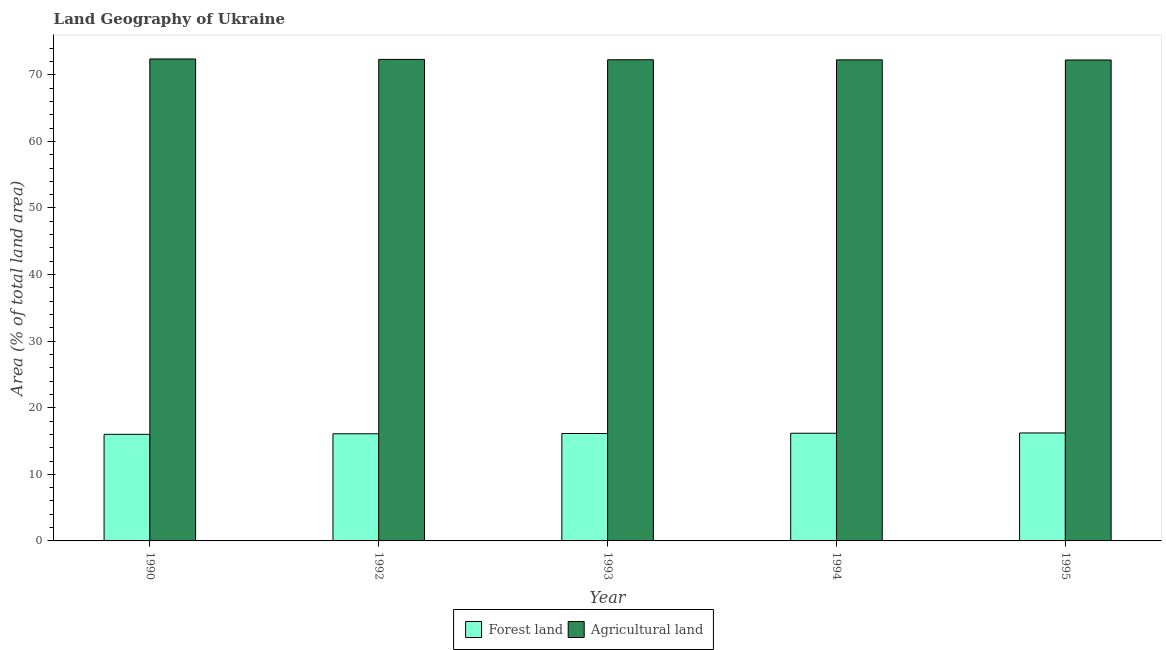How many groups of bars are there?
Give a very brief answer. 5. Are the number of bars per tick equal to the number of legend labels?
Your answer should be very brief. Yes. Are the number of bars on each tick of the X-axis equal?
Make the answer very short. Yes. How many bars are there on the 3rd tick from the left?
Make the answer very short. 2. How many bars are there on the 3rd tick from the right?
Offer a terse response. 2. What is the label of the 1st group of bars from the left?
Offer a very short reply. 1990. What is the percentage of land area under forests in 1993?
Offer a terse response. 16.13. Across all years, what is the maximum percentage of land area under forests?
Make the answer very short. 16.21. Across all years, what is the minimum percentage of land area under agriculture?
Your response must be concise. 72.22. In which year was the percentage of land area under forests minimum?
Ensure brevity in your answer.  1990. What is the total percentage of land area under agriculture in the graph?
Your response must be concise. 361.39. What is the difference between the percentage of land area under forests in 1993 and that in 1995?
Your answer should be very brief. -0.08. What is the difference between the percentage of land area under agriculture in 1994 and the percentage of land area under forests in 1995?
Give a very brief answer. 0.02. What is the average percentage of land area under forests per year?
Ensure brevity in your answer.  16.12. In the year 1995, what is the difference between the percentage of land area under agriculture and percentage of land area under forests?
Make the answer very short. 0. In how many years, is the percentage of land area under forests greater than 52 %?
Your response must be concise. 0. What is the ratio of the percentage of land area under agriculture in 1992 to that in 1993?
Your response must be concise. 1. Is the percentage of land area under forests in 1992 less than that in 1994?
Provide a short and direct response. Yes. Is the difference between the percentage of land area under agriculture in 1993 and 1994 greater than the difference between the percentage of land area under forests in 1993 and 1994?
Make the answer very short. No. What is the difference between the highest and the second highest percentage of land area under forests?
Your answer should be very brief. 0.04. What is the difference between the highest and the lowest percentage of land area under agriculture?
Provide a succinct answer. 0.15. In how many years, is the percentage of land area under agriculture greater than the average percentage of land area under agriculture taken over all years?
Provide a short and direct response. 2. What does the 1st bar from the left in 1995 represents?
Offer a very short reply. Forest land. What does the 2nd bar from the right in 1994 represents?
Make the answer very short. Forest land. How many bars are there?
Your response must be concise. 10. Are all the bars in the graph horizontal?
Give a very brief answer. No. How many years are there in the graph?
Keep it short and to the point. 5. What is the difference between two consecutive major ticks on the Y-axis?
Make the answer very short. 10. Are the values on the major ticks of Y-axis written in scientific E-notation?
Make the answer very short. No. Does the graph contain any zero values?
Your response must be concise. No. Does the graph contain grids?
Ensure brevity in your answer.  No. Where does the legend appear in the graph?
Make the answer very short. Bottom center. How many legend labels are there?
Offer a terse response. 2. How are the legend labels stacked?
Provide a short and direct response. Horizontal. What is the title of the graph?
Keep it short and to the point. Land Geography of Ukraine. Does "Male population" appear as one of the legend labels in the graph?
Ensure brevity in your answer.  No. What is the label or title of the Y-axis?
Provide a succinct answer. Area (% of total land area). What is the Area (% of total land area) of Forest land in 1990?
Your answer should be compact. 16.01. What is the Area (% of total land area) of Agricultural land in 1990?
Provide a short and direct response. 72.37. What is the Area (% of total land area) of Forest land in 1992?
Offer a terse response. 16.09. What is the Area (% of total land area) in Agricultural land in 1992?
Offer a very short reply. 72.31. What is the Area (% of total land area) of Forest land in 1993?
Provide a short and direct response. 16.13. What is the Area (% of total land area) of Agricultural land in 1993?
Give a very brief answer. 72.26. What is the Area (% of total land area) of Forest land in 1994?
Offer a very short reply. 16.17. What is the Area (% of total land area) in Agricultural land in 1994?
Your answer should be compact. 72.24. What is the Area (% of total land area) of Forest land in 1995?
Provide a short and direct response. 16.21. What is the Area (% of total land area) of Agricultural land in 1995?
Make the answer very short. 72.22. Across all years, what is the maximum Area (% of total land area) in Forest land?
Your response must be concise. 16.21. Across all years, what is the maximum Area (% of total land area) in Agricultural land?
Offer a very short reply. 72.37. Across all years, what is the minimum Area (% of total land area) of Forest land?
Offer a very short reply. 16.01. Across all years, what is the minimum Area (% of total land area) of Agricultural land?
Your response must be concise. 72.22. What is the total Area (% of total land area) in Forest land in the graph?
Provide a succinct answer. 80.61. What is the total Area (% of total land area) in Agricultural land in the graph?
Ensure brevity in your answer.  361.39. What is the difference between the Area (% of total land area) in Forest land in 1990 and that in 1992?
Provide a succinct answer. -0.08. What is the difference between the Area (% of total land area) in Agricultural land in 1990 and that in 1992?
Ensure brevity in your answer.  0.07. What is the difference between the Area (% of total land area) in Forest land in 1990 and that in 1993?
Provide a short and direct response. -0.12. What is the difference between the Area (% of total land area) in Agricultural land in 1990 and that in 1993?
Your response must be concise. 0.12. What is the difference between the Area (% of total land area) in Forest land in 1990 and that in 1994?
Offer a very short reply. -0.16. What is the difference between the Area (% of total land area) in Agricultural land in 1990 and that in 1994?
Provide a succinct answer. 0.13. What is the difference between the Area (% of total land area) in Forest land in 1990 and that in 1995?
Your response must be concise. -0.2. What is the difference between the Area (% of total land area) in Agricultural land in 1990 and that in 1995?
Ensure brevity in your answer.  0.15. What is the difference between the Area (% of total land area) of Forest land in 1992 and that in 1993?
Offer a very short reply. -0.04. What is the difference between the Area (% of total land area) in Agricultural land in 1992 and that in 1993?
Give a very brief answer. 0.05. What is the difference between the Area (% of total land area) in Forest land in 1992 and that in 1994?
Provide a short and direct response. -0.08. What is the difference between the Area (% of total land area) in Agricultural land in 1992 and that in 1994?
Your answer should be very brief. 0.06. What is the difference between the Area (% of total land area) in Forest land in 1992 and that in 1995?
Keep it short and to the point. -0.12. What is the difference between the Area (% of total land area) in Agricultural land in 1992 and that in 1995?
Make the answer very short. 0.09. What is the difference between the Area (% of total land area) in Forest land in 1993 and that in 1994?
Keep it short and to the point. -0.04. What is the difference between the Area (% of total land area) in Agricultural land in 1993 and that in 1994?
Your response must be concise. 0.01. What is the difference between the Area (% of total land area) of Forest land in 1993 and that in 1995?
Keep it short and to the point. -0.08. What is the difference between the Area (% of total land area) in Agricultural land in 1993 and that in 1995?
Provide a succinct answer. 0.04. What is the difference between the Area (% of total land area) in Forest land in 1994 and that in 1995?
Provide a succinct answer. -0.04. What is the difference between the Area (% of total land area) in Agricultural land in 1994 and that in 1995?
Keep it short and to the point. 0.02. What is the difference between the Area (% of total land area) in Forest land in 1990 and the Area (% of total land area) in Agricultural land in 1992?
Offer a very short reply. -56.3. What is the difference between the Area (% of total land area) in Forest land in 1990 and the Area (% of total land area) in Agricultural land in 1993?
Offer a very short reply. -56.25. What is the difference between the Area (% of total land area) of Forest land in 1990 and the Area (% of total land area) of Agricultural land in 1994?
Make the answer very short. -56.23. What is the difference between the Area (% of total land area) in Forest land in 1990 and the Area (% of total land area) in Agricultural land in 1995?
Your answer should be very brief. -56.21. What is the difference between the Area (% of total land area) of Forest land in 1992 and the Area (% of total land area) of Agricultural land in 1993?
Provide a succinct answer. -56.17. What is the difference between the Area (% of total land area) of Forest land in 1992 and the Area (% of total land area) of Agricultural land in 1994?
Your answer should be compact. -56.15. What is the difference between the Area (% of total land area) in Forest land in 1992 and the Area (% of total land area) in Agricultural land in 1995?
Your answer should be very brief. -56.13. What is the difference between the Area (% of total land area) of Forest land in 1993 and the Area (% of total land area) of Agricultural land in 1994?
Offer a terse response. -56.11. What is the difference between the Area (% of total land area) of Forest land in 1993 and the Area (% of total land area) of Agricultural land in 1995?
Keep it short and to the point. -56.09. What is the difference between the Area (% of total land area) in Forest land in 1994 and the Area (% of total land area) in Agricultural land in 1995?
Provide a short and direct response. -56.05. What is the average Area (% of total land area) in Forest land per year?
Give a very brief answer. 16.12. What is the average Area (% of total land area) of Agricultural land per year?
Your answer should be very brief. 72.28. In the year 1990, what is the difference between the Area (% of total land area) of Forest land and Area (% of total land area) of Agricultural land?
Ensure brevity in your answer.  -56.36. In the year 1992, what is the difference between the Area (% of total land area) of Forest land and Area (% of total land area) of Agricultural land?
Offer a terse response. -56.22. In the year 1993, what is the difference between the Area (% of total land area) in Forest land and Area (% of total land area) in Agricultural land?
Offer a very short reply. -56.13. In the year 1994, what is the difference between the Area (% of total land area) in Forest land and Area (% of total land area) in Agricultural land?
Your response must be concise. -56.07. In the year 1995, what is the difference between the Area (% of total land area) in Forest land and Area (% of total land area) in Agricultural land?
Your response must be concise. -56.01. What is the ratio of the Area (% of total land area) of Agricultural land in 1990 to that in 1992?
Provide a short and direct response. 1. What is the ratio of the Area (% of total land area) of Forest land in 1990 to that in 1993?
Keep it short and to the point. 0.99. What is the ratio of the Area (% of total land area) in Agricultural land in 1990 to that in 1993?
Provide a succinct answer. 1. What is the ratio of the Area (% of total land area) in Forest land in 1990 to that in 1994?
Offer a very short reply. 0.99. What is the ratio of the Area (% of total land area) in Forest land in 1990 to that in 1995?
Give a very brief answer. 0.99. What is the ratio of the Area (% of total land area) in Forest land in 1992 to that in 1994?
Keep it short and to the point. 0.99. What is the ratio of the Area (% of total land area) of Agricultural land in 1992 to that in 1994?
Make the answer very short. 1. What is the ratio of the Area (% of total land area) of Forest land in 1992 to that in 1995?
Keep it short and to the point. 0.99. What is the ratio of the Area (% of total land area) in Forest land in 1993 to that in 1994?
Provide a succinct answer. 1. What is the ratio of the Area (% of total land area) in Agricultural land in 1993 to that in 1995?
Offer a very short reply. 1. What is the ratio of the Area (% of total land area) in Forest land in 1994 to that in 1995?
Your answer should be very brief. 1. What is the difference between the highest and the second highest Area (% of total land area) in Forest land?
Your answer should be very brief. 0.04. What is the difference between the highest and the second highest Area (% of total land area) of Agricultural land?
Provide a succinct answer. 0.07. What is the difference between the highest and the lowest Area (% of total land area) in Forest land?
Make the answer very short. 0.2. What is the difference between the highest and the lowest Area (% of total land area) of Agricultural land?
Keep it short and to the point. 0.15. 